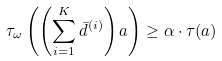<formula> <loc_0><loc_0><loc_500><loc_500>\tau _ { \omega } \left ( \left ( \sum _ { i = 1 } ^ { K } \bar { d } ^ { ( i ) } \right ) a \right ) \geq \alpha \cdot \tau ( a )</formula> 